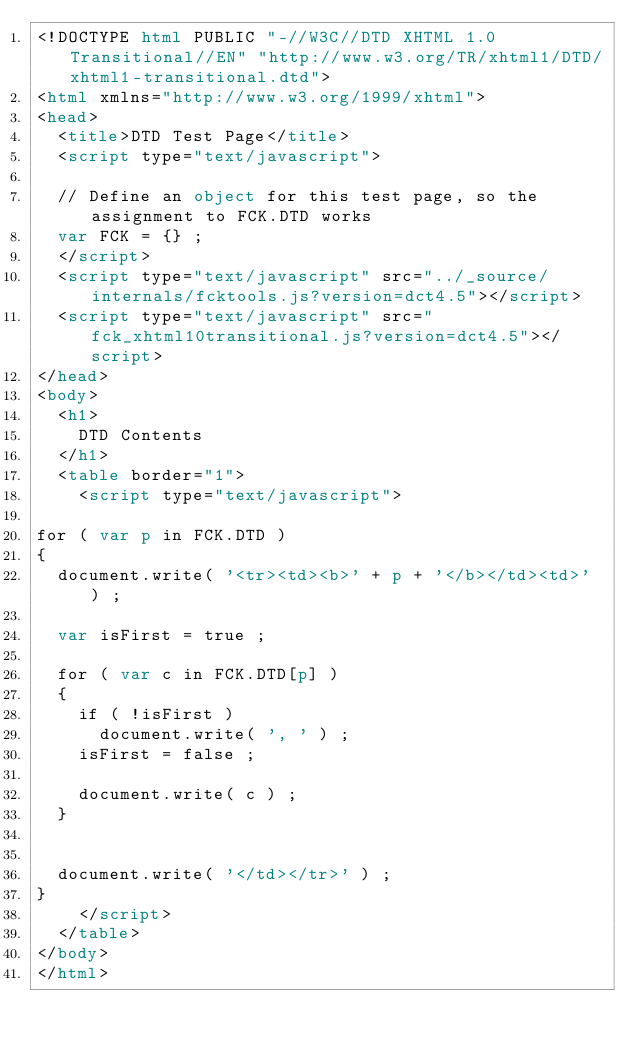Convert code to text. <code><loc_0><loc_0><loc_500><loc_500><_HTML_><!DOCTYPE html PUBLIC "-//W3C//DTD XHTML 1.0 Transitional//EN" "http://www.w3.org/TR/xhtml1/DTD/xhtml1-transitional.dtd">
<html xmlns="http://www.w3.org/1999/xhtml">
<head>
	<title>DTD Test Page</title>
	<script type="text/javascript">

	// Define an object for this test page, so the assignment to FCK.DTD works
	var FCK = {} ;
	</script>
	<script type="text/javascript" src="../_source/internals/fcktools.js?version=dct4.5"></script>
	<script type="text/javascript" src="fck_xhtml10transitional.js?version=dct4.5"></script>
</head>
<body>
	<h1>
		DTD Contents
	</h1>
	<table border="1">
		<script type="text/javascript">

for ( var p in FCK.DTD )
{
	document.write( '<tr><td><b>' + p + '</b></td><td>' ) ;

	var isFirst = true ;

	for ( var c in FCK.DTD[p] )
	{
		if ( !isFirst )
			document.write( ', ' ) ;
		isFirst = false ;

		document.write( c ) ;
	}


	document.write( '</td></tr>' ) ;
}
		</script>
	</table>
</body>
</html>
</code> 